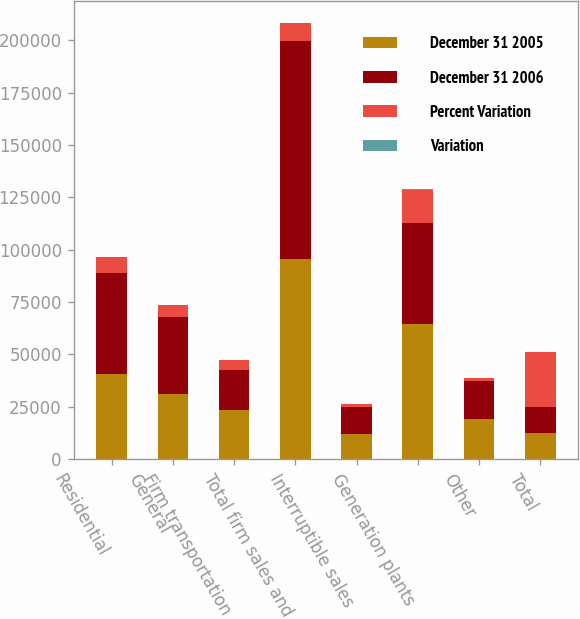<chart> <loc_0><loc_0><loc_500><loc_500><stacked_bar_chart><ecel><fcel>Residential<fcel>General<fcel>Firm transportation<fcel>Total firm sales and<fcel>Interruptible sales<fcel>Generation plants<fcel>Other<fcel>Total<nl><fcel>December 31 2005<fcel>40589<fcel>31269<fcel>23688<fcel>95546<fcel>11995<fcel>64365<fcel>19324<fcel>12561.5<nl><fcel>December 31 2006<fcel>48175<fcel>36800<fcel>19088<fcel>104063<fcel>13128<fcel>48564<fcel>18103<fcel>12561.5<nl><fcel>Percent Variation<fcel>7586<fcel>5531<fcel>4600<fcel>8517<fcel>1133<fcel>15801<fcel>1221<fcel>26124<nl><fcel>Variation<fcel>15.7<fcel>15<fcel>24.1<fcel>8.2<fcel>8.6<fcel>32.5<fcel>6.7<fcel>12.7<nl></chart> 